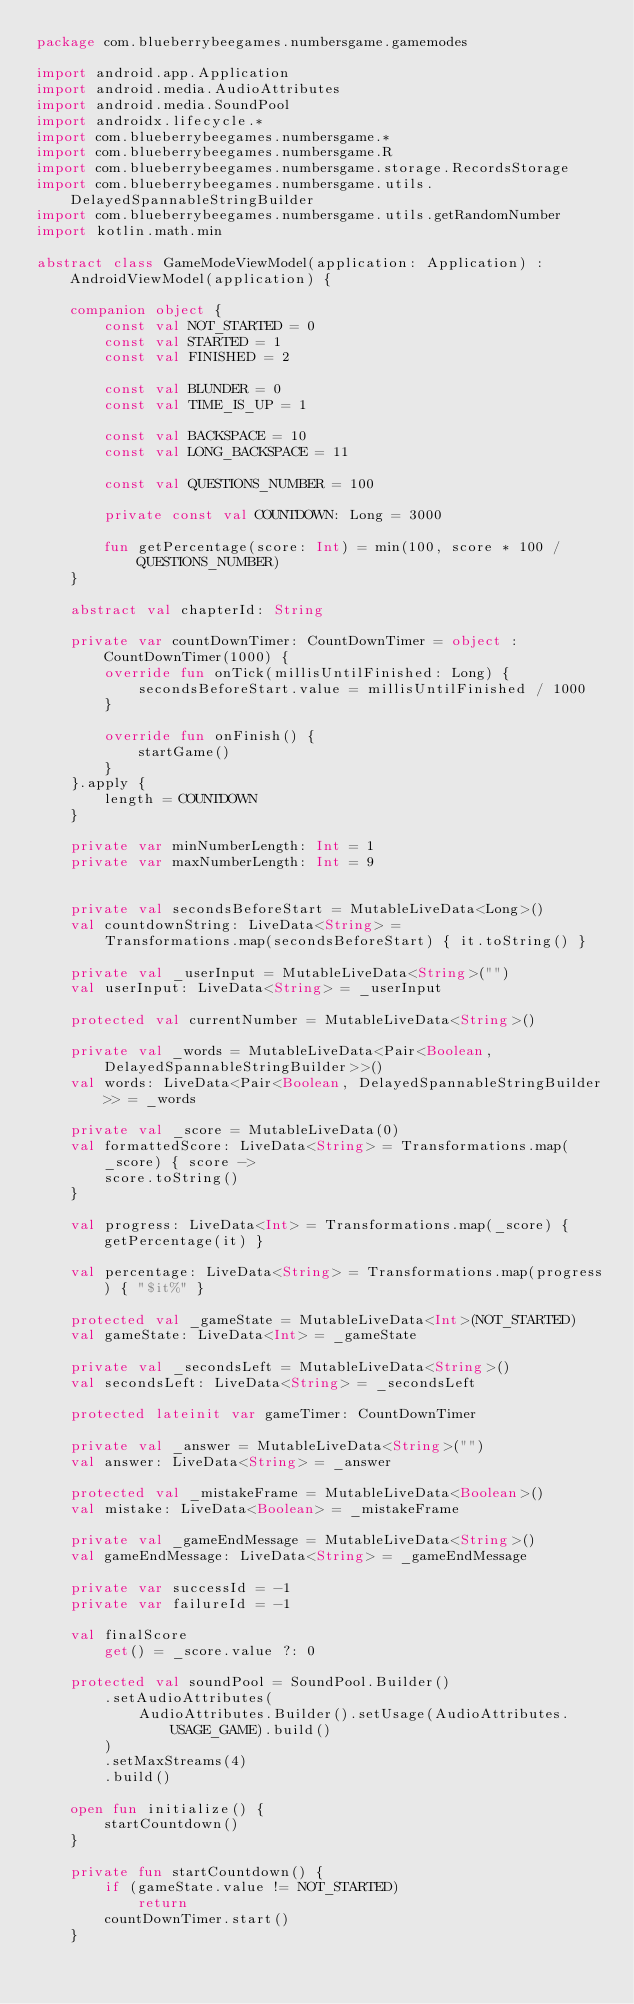<code> <loc_0><loc_0><loc_500><loc_500><_Kotlin_>package com.blueberrybeegames.numbersgame.gamemodes

import android.app.Application
import android.media.AudioAttributes
import android.media.SoundPool
import androidx.lifecycle.*
import com.blueberrybeegames.numbersgame.*
import com.blueberrybeegames.numbersgame.R
import com.blueberrybeegames.numbersgame.storage.RecordsStorage
import com.blueberrybeegames.numbersgame.utils.DelayedSpannableStringBuilder
import com.blueberrybeegames.numbersgame.utils.getRandomNumber
import kotlin.math.min

abstract class GameModeViewModel(application: Application) : AndroidViewModel(application) {

    companion object {
        const val NOT_STARTED = 0
        const val STARTED = 1
        const val FINISHED = 2

        const val BLUNDER = 0
        const val TIME_IS_UP = 1

        const val BACKSPACE = 10
        const val LONG_BACKSPACE = 11

        const val QUESTIONS_NUMBER = 100

        private const val COUNTDOWN: Long = 3000

        fun getPercentage(score: Int) = min(100, score * 100 / QUESTIONS_NUMBER)
    }

    abstract val chapterId: String

    private var countDownTimer: CountDownTimer = object : CountDownTimer(1000) {
        override fun onTick(millisUntilFinished: Long) {
            secondsBeforeStart.value = millisUntilFinished / 1000
        }

        override fun onFinish() {
            startGame()
        }
    }.apply {
        length = COUNTDOWN
    }

    private var minNumberLength: Int = 1
    private var maxNumberLength: Int = 9


    private val secondsBeforeStart = MutableLiveData<Long>()
    val countdownString: LiveData<String> =
        Transformations.map(secondsBeforeStart) { it.toString() }

    private val _userInput = MutableLiveData<String>("")
    val userInput: LiveData<String> = _userInput

    protected val currentNumber = MutableLiveData<String>()

    private val _words = MutableLiveData<Pair<Boolean, DelayedSpannableStringBuilder>>()
    val words: LiveData<Pair<Boolean, DelayedSpannableStringBuilder>> = _words

    private val _score = MutableLiveData(0)
    val formattedScore: LiveData<String> = Transformations.map(_score) { score ->
        score.toString()
    }

    val progress: LiveData<Int> = Transformations.map(_score) { getPercentage(it) }

    val percentage: LiveData<String> = Transformations.map(progress) { "$it%" }

    protected val _gameState = MutableLiveData<Int>(NOT_STARTED)
    val gameState: LiveData<Int> = _gameState

    private val _secondsLeft = MutableLiveData<String>()
    val secondsLeft: LiveData<String> = _secondsLeft

    protected lateinit var gameTimer: CountDownTimer

    private val _answer = MutableLiveData<String>("")
    val answer: LiveData<String> = _answer

    protected val _mistakeFrame = MutableLiveData<Boolean>()
    val mistake: LiveData<Boolean> = _mistakeFrame

    private val _gameEndMessage = MutableLiveData<String>()
    val gameEndMessage: LiveData<String> = _gameEndMessage

    private var successId = -1
    private var failureId = -1

    val finalScore
        get() = _score.value ?: 0

    protected val soundPool = SoundPool.Builder()
        .setAudioAttributes(
            AudioAttributes.Builder().setUsage(AudioAttributes.USAGE_GAME).build()
        )
        .setMaxStreams(4)
        .build()

    open fun initialize() {
        startCountdown()
    }

    private fun startCountdown() {
        if (gameState.value != NOT_STARTED)
            return
        countDownTimer.start()
    }
</code> 